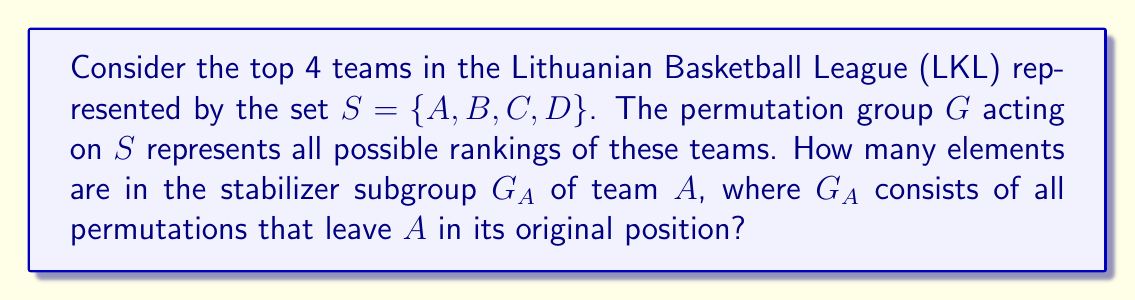Teach me how to tackle this problem. Let's approach this step-by-step:

1) First, recall that the stabilizer subgroup $G_A$ consists of all permutations in $G$ that fix the element $A$.

2) In the context of LKL rankings, this means we're looking for all possible ways to arrange the other teams while keeping team $A$ in its original position.

3) We have 4 teams in total, represented by the set $S = \{A, B, C, D\}$.

4) To count the elements in $G_A$, we need to count how many ways we can arrange the remaining 3 teams (B, C, and D) while A stays fixed.

5) This is equivalent to finding the number of permutations of 3 elements, which is given by $3!$ (3 factorial).

6) Calculate $3! = 3 \times 2 \times 1 = 6$

Therefore, there are 6 elements in the stabilizer subgroup $G_A$.

To verify, we can list out all these permutations:
   $(A,B,C,D)$, $(A,B,D,C)$, $(A,C,B,D)$, $(A,C,D,B)$, $(A,D,B,C)$, $(A,D,C,B)$

Each of these permutations keeps A in its original position while rearranging the other teams.
Answer: 6 